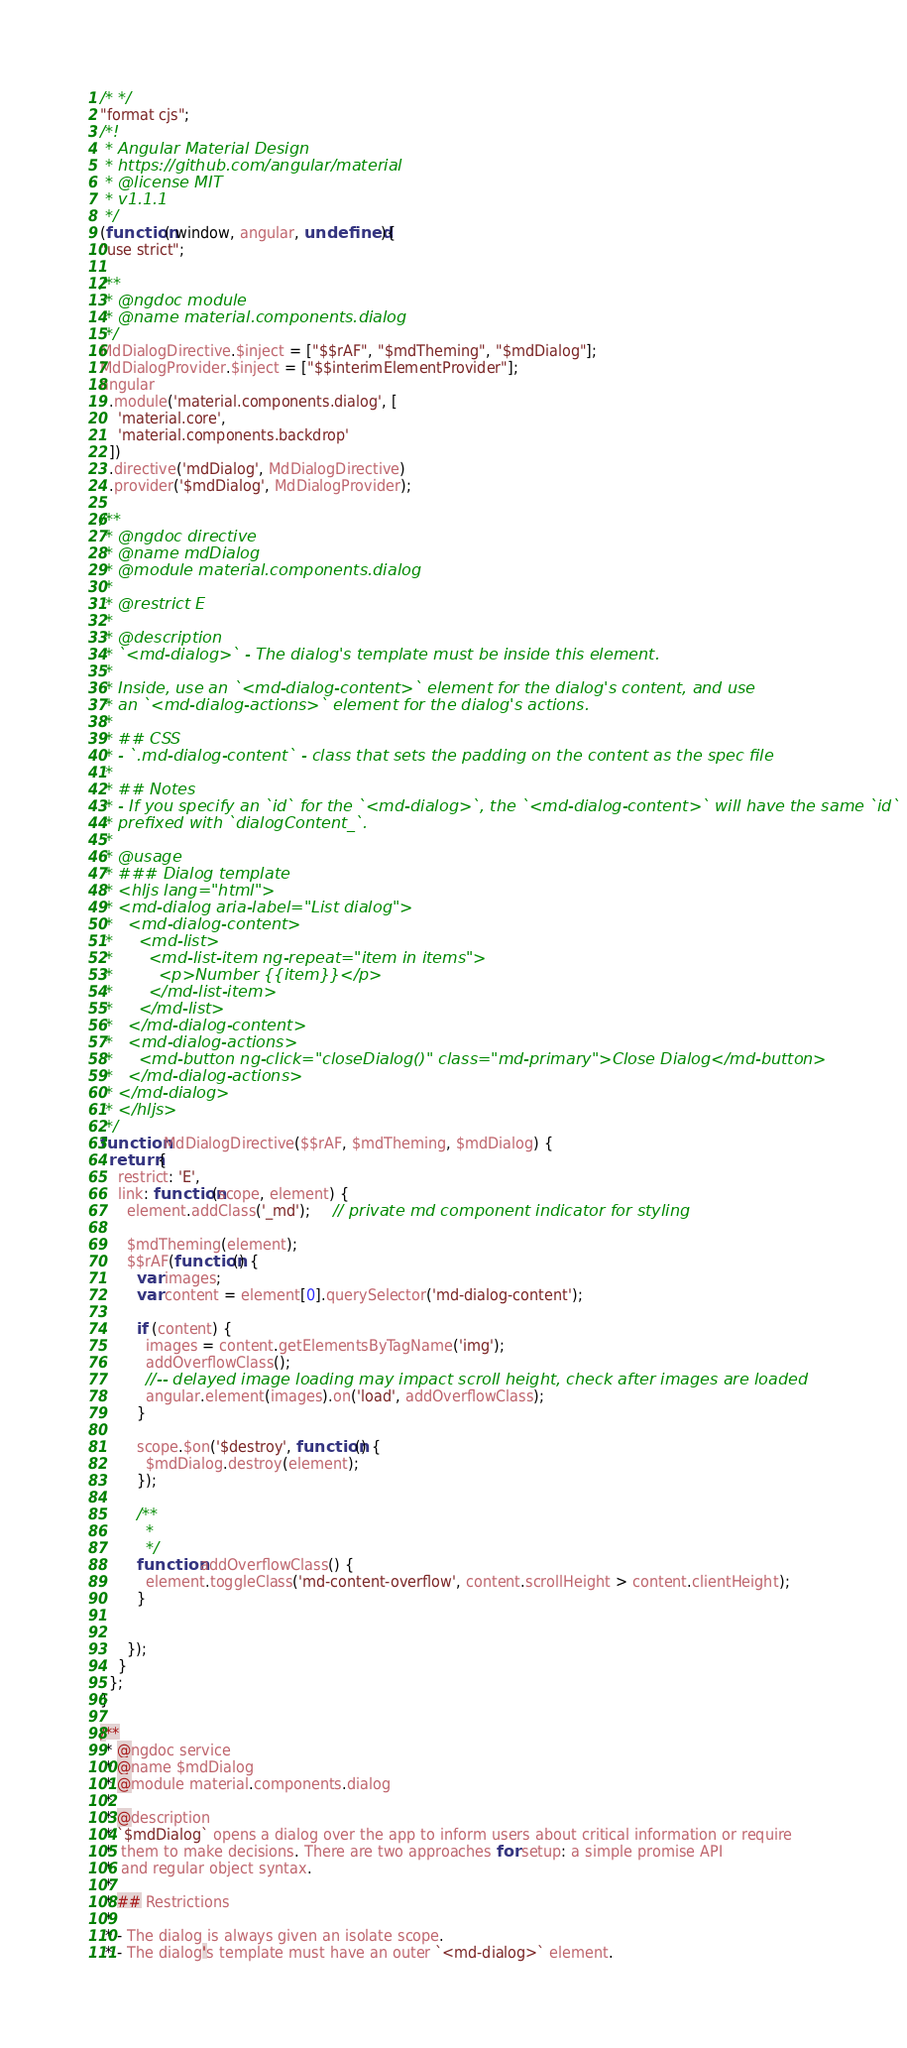<code> <loc_0><loc_0><loc_500><loc_500><_JavaScript_>/* */ 
"format cjs";
/*!
 * Angular Material Design
 * https://github.com/angular/material
 * @license MIT
 * v1.1.1
 */
(function( window, angular, undefined ){
"use strict";

/**
 * @ngdoc module
 * @name material.components.dialog
 */
MdDialogDirective.$inject = ["$$rAF", "$mdTheming", "$mdDialog"];
MdDialogProvider.$inject = ["$$interimElementProvider"];
angular
  .module('material.components.dialog', [
    'material.core',
    'material.components.backdrop'
  ])
  .directive('mdDialog', MdDialogDirective)
  .provider('$mdDialog', MdDialogProvider);

/**
 * @ngdoc directive
 * @name mdDialog
 * @module material.components.dialog
 *
 * @restrict E
 *
 * @description
 * `<md-dialog>` - The dialog's template must be inside this element.
 *
 * Inside, use an `<md-dialog-content>` element for the dialog's content, and use
 * an `<md-dialog-actions>` element for the dialog's actions.
 *
 * ## CSS
 * - `.md-dialog-content` - class that sets the padding on the content as the spec file
 *
 * ## Notes
 * - If you specify an `id` for the `<md-dialog>`, the `<md-dialog-content>` will have the same `id`
 * prefixed with `dialogContent_`.
 *
 * @usage
 * ### Dialog template
 * <hljs lang="html">
 * <md-dialog aria-label="List dialog">
 *   <md-dialog-content>
 *     <md-list>
 *       <md-list-item ng-repeat="item in items">
 *         <p>Number {{item}}</p>
 *       </md-list-item>
 *     </md-list>
 *   </md-dialog-content>
 *   <md-dialog-actions>
 *     <md-button ng-click="closeDialog()" class="md-primary">Close Dialog</md-button>
 *   </md-dialog-actions>
 * </md-dialog>
 * </hljs>
 */
function MdDialogDirective($$rAF, $mdTheming, $mdDialog) {
  return {
    restrict: 'E',
    link: function(scope, element) {
      element.addClass('_md');     // private md component indicator for styling

      $mdTheming(element);
      $$rAF(function() {
        var images;
        var content = element[0].querySelector('md-dialog-content');

        if (content) {
          images = content.getElementsByTagName('img');
          addOverflowClass();
          //-- delayed image loading may impact scroll height, check after images are loaded
          angular.element(images).on('load', addOverflowClass);
        }

        scope.$on('$destroy', function() {
          $mdDialog.destroy(element);
        });

        /**
         *
         */
        function addOverflowClass() {
          element.toggleClass('md-content-overflow', content.scrollHeight > content.clientHeight);
        }


      });
    }
  };
}

/**
 * @ngdoc service
 * @name $mdDialog
 * @module material.components.dialog
 *
 * @description
 * `$mdDialog` opens a dialog over the app to inform users about critical information or require
 *  them to make decisions. There are two approaches for setup: a simple promise API
 *  and regular object syntax.
 *
 * ## Restrictions
 *
 * - The dialog is always given an isolate scope.
 * - The dialog's template must have an outer `<md-dialog>` element.</code> 